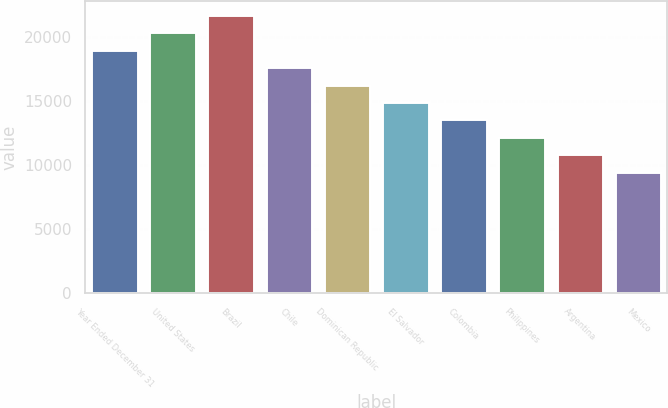Convert chart to OTSL. <chart><loc_0><loc_0><loc_500><loc_500><bar_chart><fcel>Year Ended December 31<fcel>United States<fcel>Brazil<fcel>Chile<fcel>Dominican Republic<fcel>El Salvador<fcel>Colombia<fcel>Philippines<fcel>Argentina<fcel>Mexico<nl><fcel>19017.2<fcel>20375<fcel>21732.8<fcel>17659.4<fcel>16301.6<fcel>14943.8<fcel>13586<fcel>12228.2<fcel>10870.4<fcel>9512.6<nl></chart> 